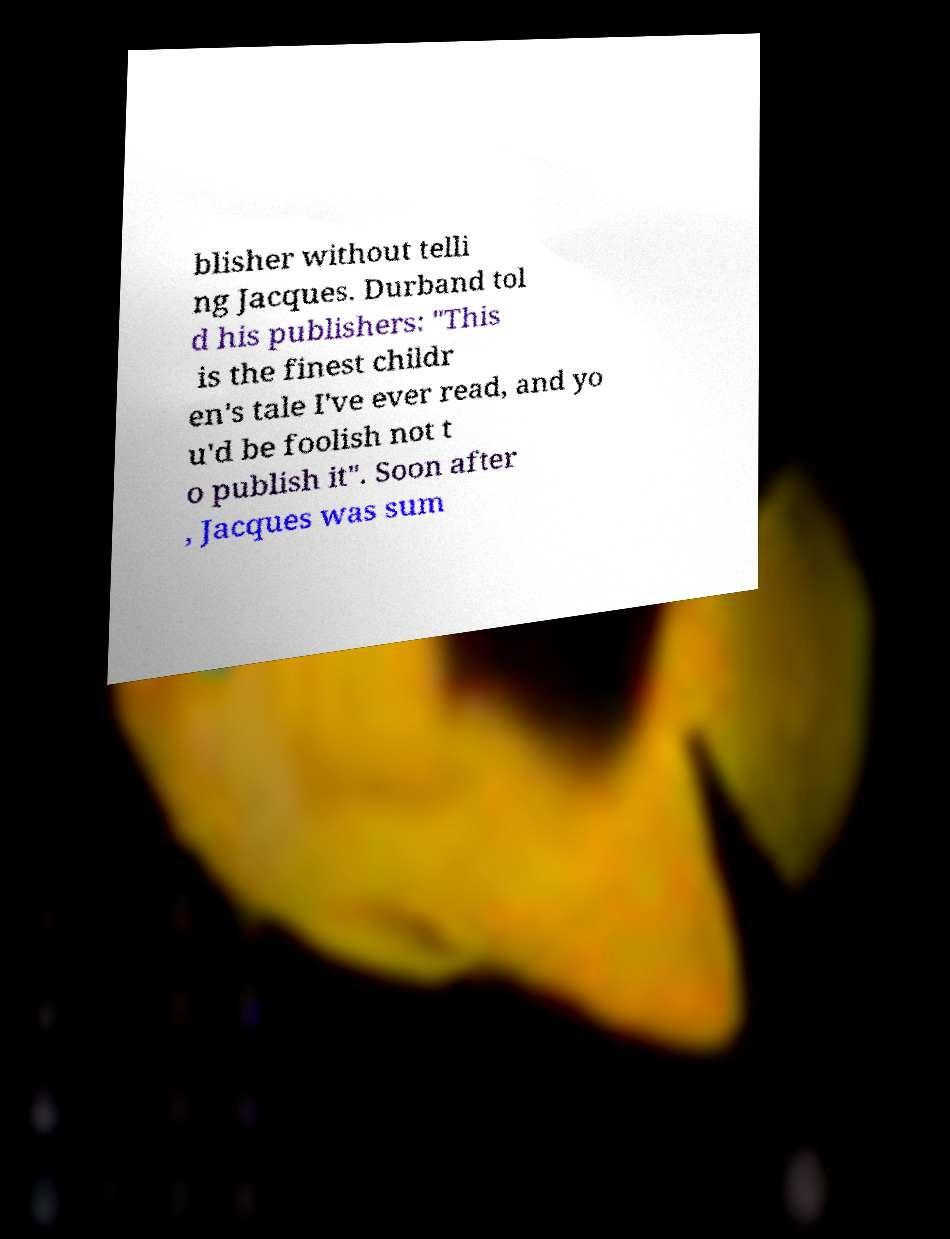There's text embedded in this image that I need extracted. Can you transcribe it verbatim? blisher without telli ng Jacques. Durband tol d his publishers: "This is the finest childr en's tale I've ever read, and yo u'd be foolish not t o publish it". Soon after , Jacques was sum 